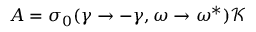<formula> <loc_0><loc_0><loc_500><loc_500>A = \sigma _ { 0 } ( \gamma \rightarrow - \gamma , \omega \rightarrow \omega ^ { * } ) \mathcal { K }</formula> 